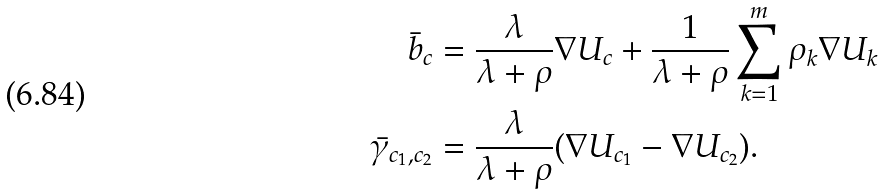Convert formula to latex. <formula><loc_0><loc_0><loc_500><loc_500>\bar { b } _ { c } & = \frac { \lambda } { \lambda + \rho } \nabla U _ { c } + \frac { 1 } { \lambda + \rho } \sum _ { k = 1 } ^ { m } \rho _ { k } \nabla U _ { k } \\ \bar { \gamma } _ { c _ { 1 } , c _ { 2 } } & = \frac { \lambda } { \lambda + \rho } ( \nabla U _ { c _ { 1 } } - \nabla U _ { c _ { 2 } } ) .</formula> 